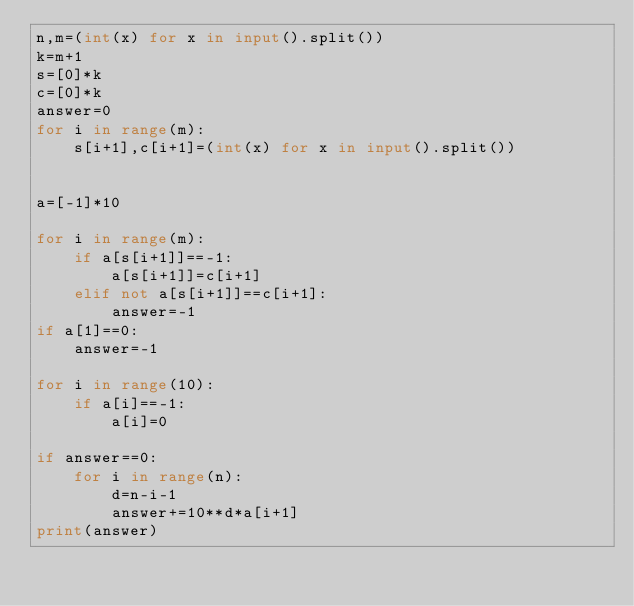Convert code to text. <code><loc_0><loc_0><loc_500><loc_500><_Python_>n,m=(int(x) for x in input().split())
k=m+1
s=[0]*k
c=[0]*k
answer=0
for i in range(m):
    s[i+1],c[i+1]=(int(x) for x in input().split())


a=[-1]*10

for i in range(m):
    if a[s[i+1]]==-1:
        a[s[i+1]]=c[i+1]
    elif not a[s[i+1]]==c[i+1]:
        answer=-1
if a[1]==0:
    answer=-1

for i in range(10):
    if a[i]==-1:
        a[i]=0

if answer==0:
    for i in range(n):
        d=n-i-1
        answer+=10**d*a[i+1]
print(answer)</code> 